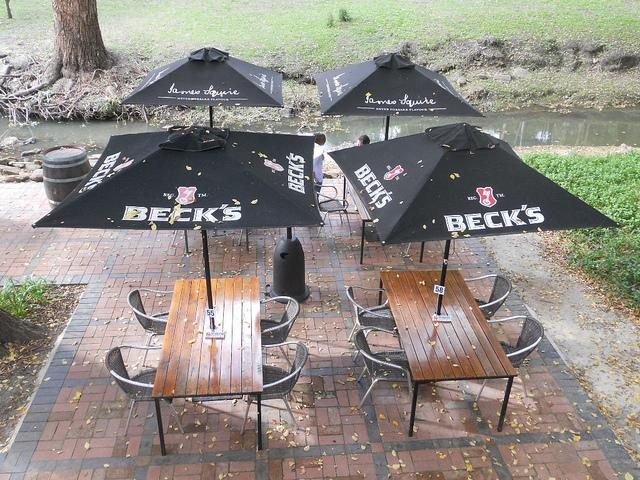What is this patio located next to? stream 